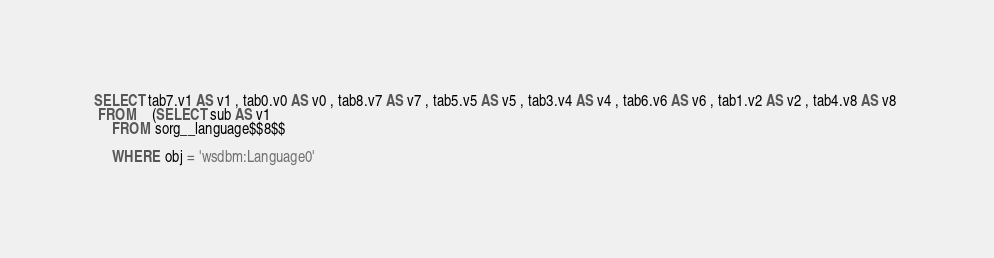<code> <loc_0><loc_0><loc_500><loc_500><_SQL_>SELECT tab7.v1 AS v1 , tab0.v0 AS v0 , tab8.v7 AS v7 , tab5.v5 AS v5 , tab3.v4 AS v4 , tab6.v6 AS v6 , tab1.v2 AS v2 , tab4.v8 AS v8 
 FROM    (SELECT sub AS v1 
	 FROM sorg__language$$8$$
	 
	 WHERE obj = 'wsdbm:Language0'</code> 